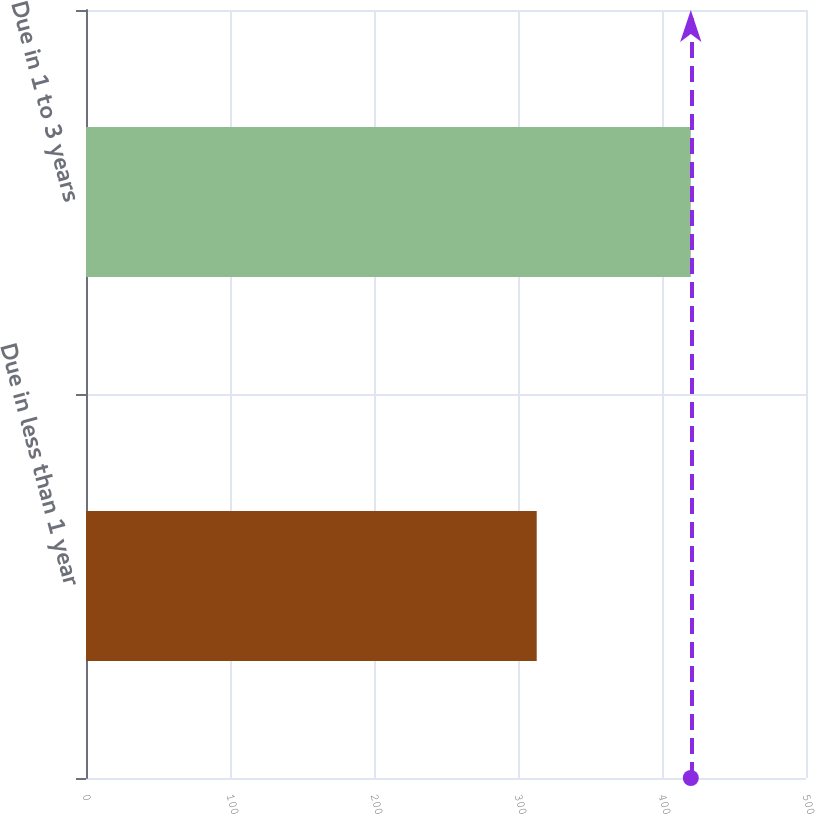<chart> <loc_0><loc_0><loc_500><loc_500><bar_chart><fcel>Due in less than 1 year<fcel>Due in 1 to 3 years<nl><fcel>313<fcel>420<nl></chart> 